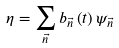Convert formula to latex. <formula><loc_0><loc_0><loc_500><loc_500>\eta = \sum _ { \vec { n } } b _ { \vec { n } } \left ( t \right ) \psi _ { \vec { n } }</formula> 